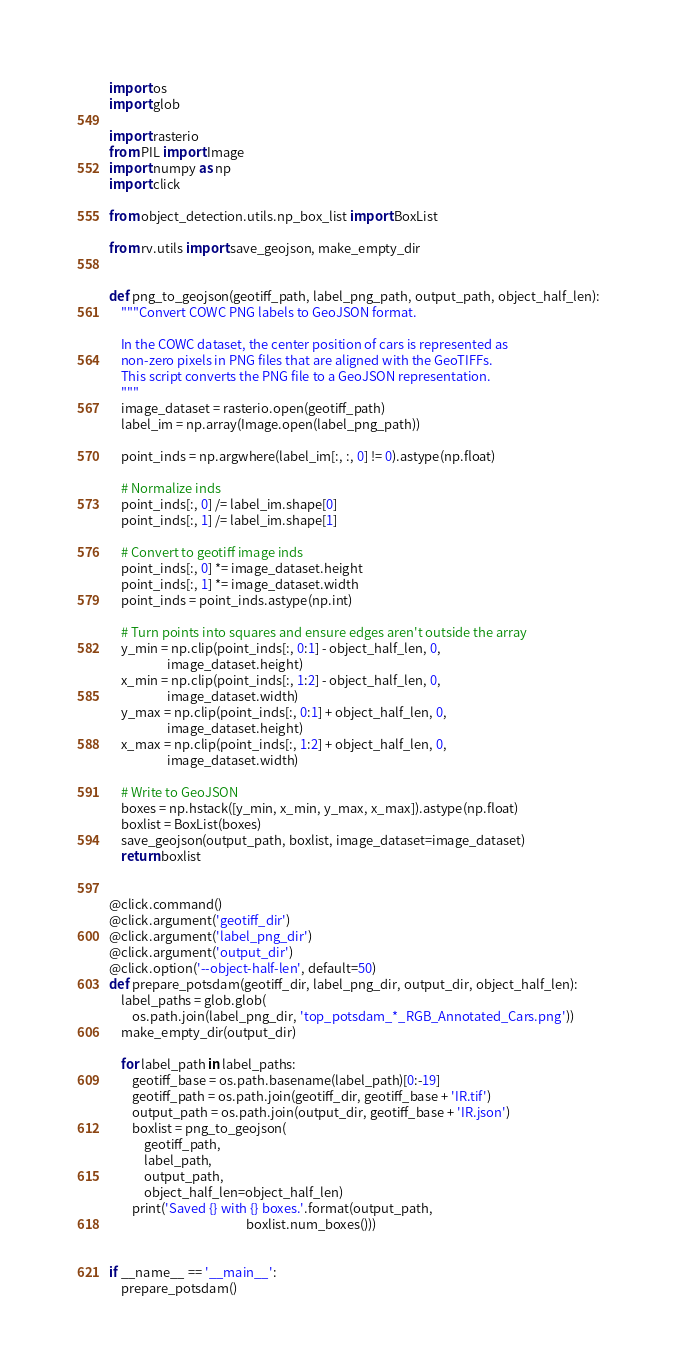<code> <loc_0><loc_0><loc_500><loc_500><_Python_>import os
import glob

import rasterio
from PIL import Image
import numpy as np
import click

from object_detection.utils.np_box_list import BoxList

from rv.utils import save_geojson, make_empty_dir


def png_to_geojson(geotiff_path, label_png_path, output_path, object_half_len):
    """Convert COWC PNG labels to GeoJSON format.

    In the COWC dataset, the center position of cars is represented as
    non-zero pixels in PNG files that are aligned with the GeoTIFFs.
    This script converts the PNG file to a GeoJSON representation.
    """
    image_dataset = rasterio.open(geotiff_path)
    label_im = np.array(Image.open(label_png_path))

    point_inds = np.argwhere(label_im[:, :, 0] != 0).astype(np.float)

    # Normalize inds
    point_inds[:, 0] /= label_im.shape[0]
    point_inds[:, 1] /= label_im.shape[1]

    # Convert to geotiff image inds
    point_inds[:, 0] *= image_dataset.height
    point_inds[:, 1] *= image_dataset.width
    point_inds = point_inds.astype(np.int)

    # Turn points into squares and ensure edges aren't outside the array
    y_min = np.clip(point_inds[:, 0:1] - object_half_len, 0,
                    image_dataset.height)
    x_min = np.clip(point_inds[:, 1:2] - object_half_len, 0,
                    image_dataset.width)
    y_max = np.clip(point_inds[:, 0:1] + object_half_len, 0,
                    image_dataset.height)
    x_max = np.clip(point_inds[:, 1:2] + object_half_len, 0,
                    image_dataset.width)

    # Write to GeoJSON
    boxes = np.hstack([y_min, x_min, y_max, x_max]).astype(np.float)
    boxlist = BoxList(boxes)
    save_geojson(output_path, boxlist, image_dataset=image_dataset)
    return boxlist


@click.command()
@click.argument('geotiff_dir')
@click.argument('label_png_dir')
@click.argument('output_dir')
@click.option('--object-half-len', default=50)
def prepare_potsdam(geotiff_dir, label_png_dir, output_dir, object_half_len):
    label_paths = glob.glob(
        os.path.join(label_png_dir, 'top_potsdam_*_RGB_Annotated_Cars.png'))
    make_empty_dir(output_dir)

    for label_path in label_paths:
        geotiff_base = os.path.basename(label_path)[0:-19]
        geotiff_path = os.path.join(geotiff_dir, geotiff_base + 'IR.tif')
        output_path = os.path.join(output_dir, geotiff_base + 'IR.json')
        boxlist = png_to_geojson(
            geotiff_path,
            label_path,
            output_path,
            object_half_len=object_half_len)
        print('Saved {} with {} boxes.'.format(output_path,
                                               boxlist.num_boxes()))


if __name__ == '__main__':
    prepare_potsdam()
</code> 